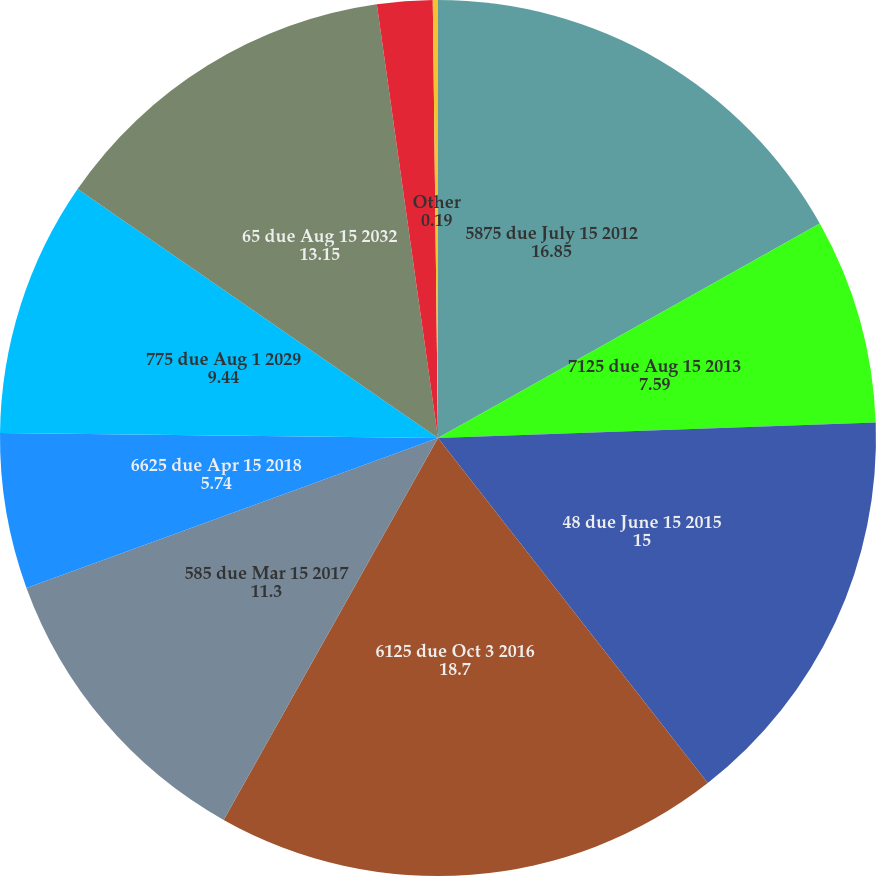Convert chart to OTSL. <chart><loc_0><loc_0><loc_500><loc_500><pie_chart><fcel>5875 due July 15 2012<fcel>7125 due Aug 15 2013<fcel>48 due June 15 2015<fcel>6125 due Oct 3 2016<fcel>585 due Mar 15 2017<fcel>6625 due Apr 15 2018<fcel>775 due Aug 1 2029<fcel>65 due Aug 15 2032<fcel>Zero Coupon Convertible Senior<fcel>Other<nl><fcel>16.85%<fcel>7.59%<fcel>15.0%<fcel>18.7%<fcel>11.3%<fcel>5.74%<fcel>9.44%<fcel>13.15%<fcel>2.04%<fcel>0.19%<nl></chart> 